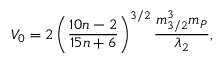Convert formula to latex. <formula><loc_0><loc_0><loc_500><loc_500>V _ { 0 } = 2 \left ( \frac { 1 0 n - 2 } { 1 5 n + 6 } \right ) ^ { 3 / 2 } \frac { m _ { 3 / 2 } ^ { 3 } m _ { P } } { \lambda _ { 2 } } ,</formula> 